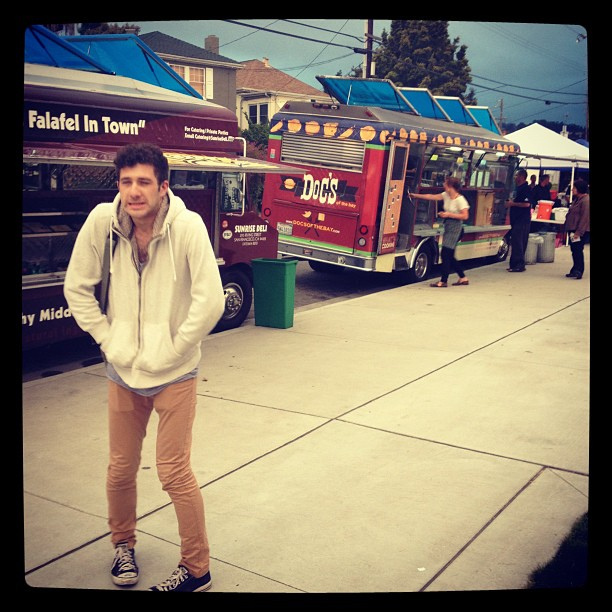<image>What does the red sign say? I am not sure. The red sign could say "doc's" or "falafel in town". What does the red sign say? I am not sure what the red sign says. It can be seen "doc's" or "falafel in town". 